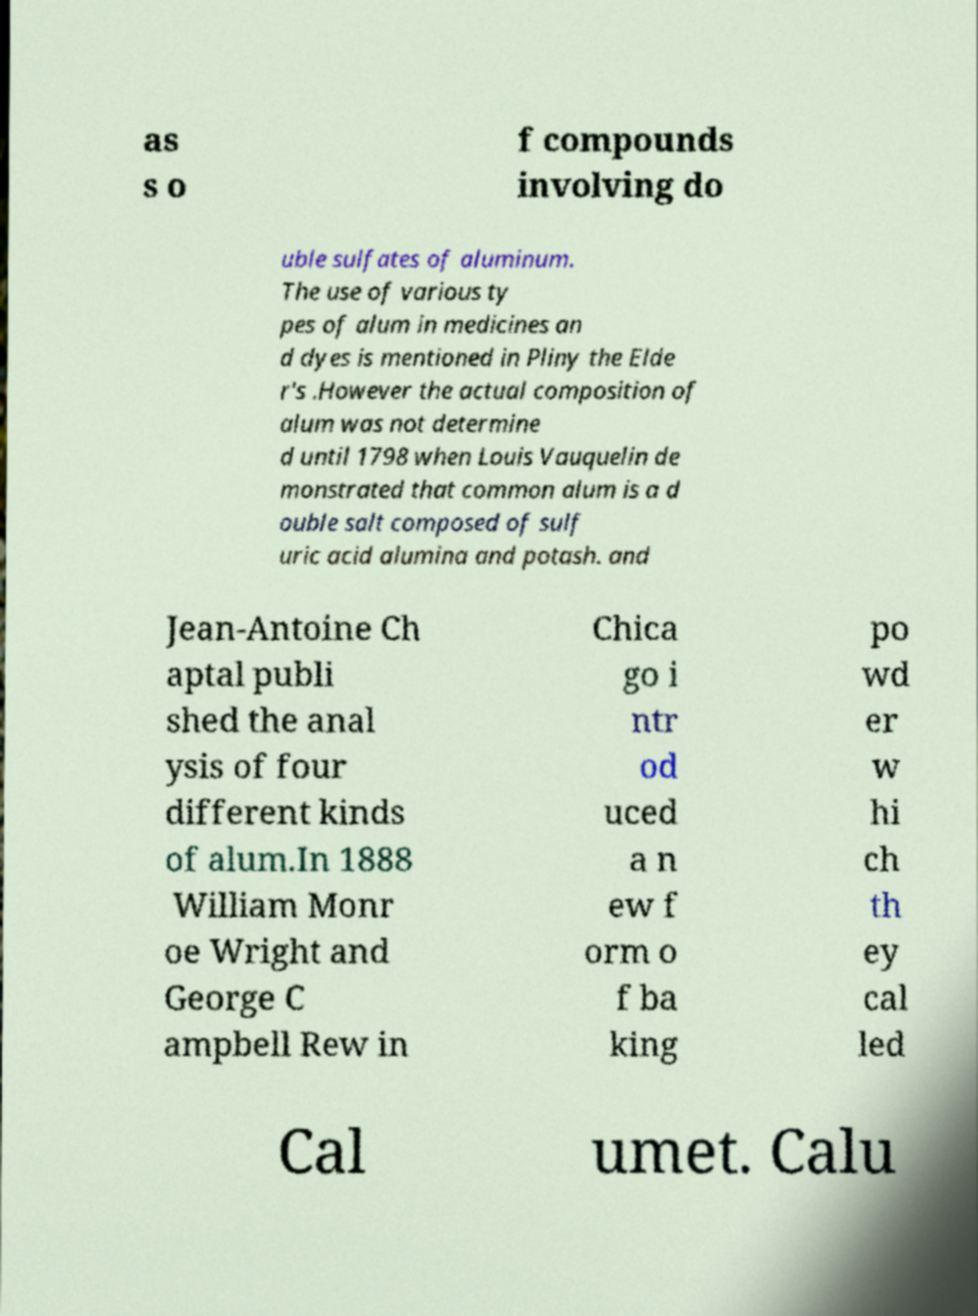What messages or text are displayed in this image? I need them in a readable, typed format. as s o f compounds involving do uble sulfates of aluminum. The use of various ty pes of alum in medicines an d dyes is mentioned in Pliny the Elde r's .However the actual composition of alum was not determine d until 1798 when Louis Vauquelin de monstrated that common alum is a d ouble salt composed of sulf uric acid alumina and potash. and Jean-Antoine Ch aptal publi shed the anal ysis of four different kinds of alum.In 1888 William Monr oe Wright and George C ampbell Rew in Chica go i ntr od uced a n ew f orm o f ba king po wd er w hi ch th ey cal led Cal umet. Calu 